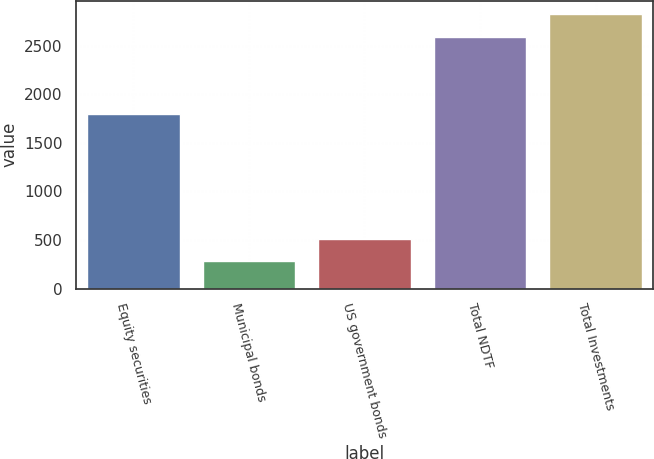Convert chart to OTSL. <chart><loc_0><loc_0><loc_500><loc_500><bar_chart><fcel>Equity securities<fcel>Municipal bonds<fcel>US government bonds<fcel>Total NDTF<fcel>Total Investments<nl><fcel>1795<fcel>283<fcel>513.9<fcel>2591<fcel>2821.9<nl></chart> 